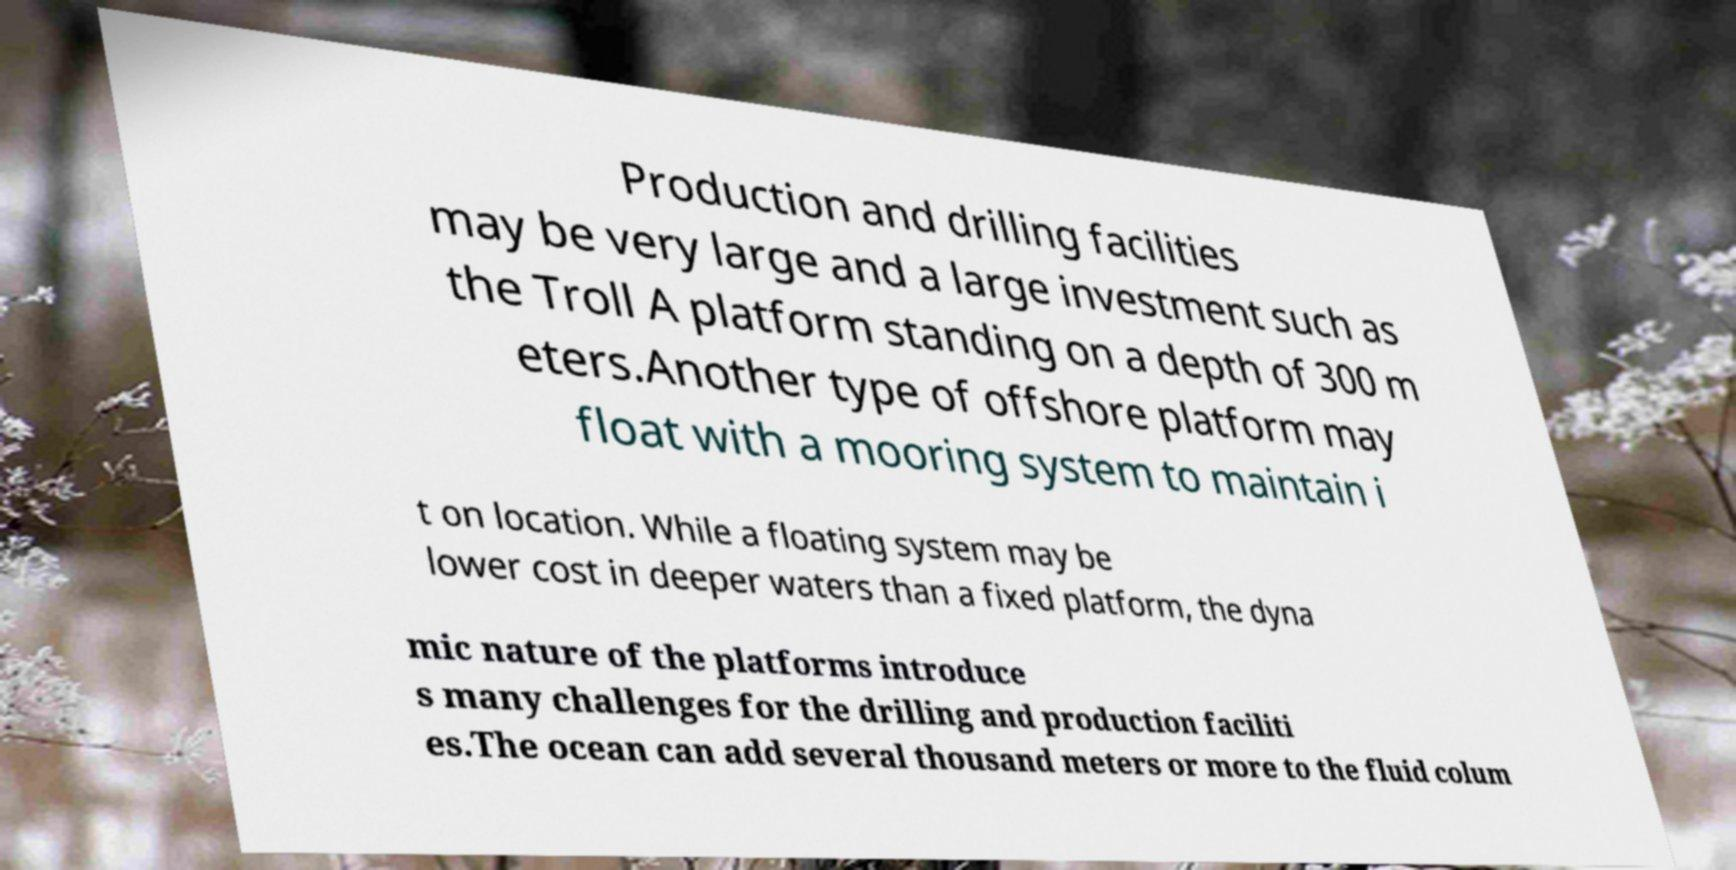Please read and relay the text visible in this image. What does it say? Production and drilling facilities may be very large and a large investment such as the Troll A platform standing on a depth of 300 m eters.Another type of offshore platform may float with a mooring system to maintain i t on location. While a floating system may be lower cost in deeper waters than a fixed platform, the dyna mic nature of the platforms introduce s many challenges for the drilling and production faciliti es.The ocean can add several thousand meters or more to the fluid colum 